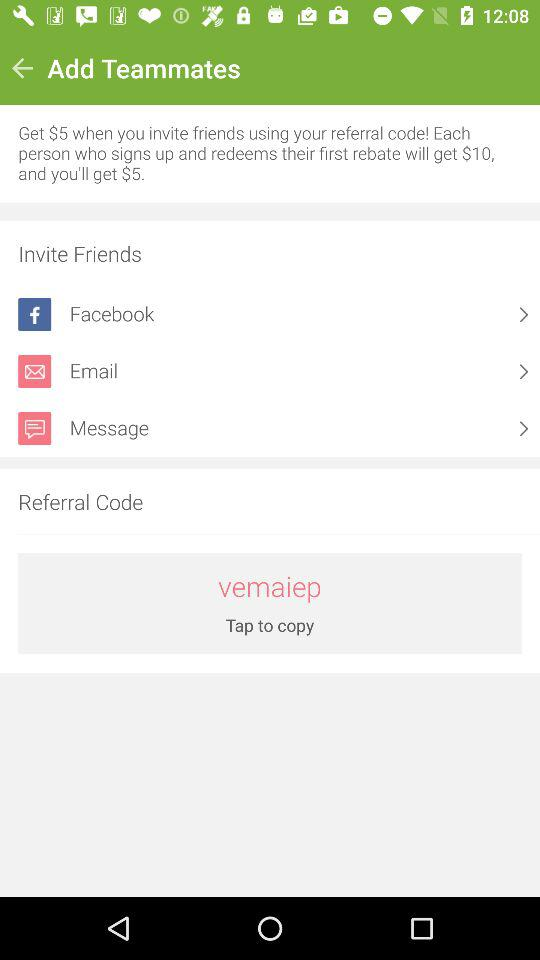What amount does each person get when they redeem their first rebate? Each person gets $10 when they redeem their first rebate. 